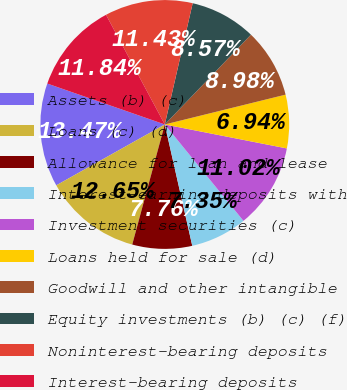Convert chart. <chart><loc_0><loc_0><loc_500><loc_500><pie_chart><fcel>Assets (b) (c)<fcel>Loans (c) (d)<fcel>Allowance for loan and lease<fcel>Interest-earning deposits with<fcel>Investment securities (c)<fcel>Loans held for sale (d)<fcel>Goodwill and other intangible<fcel>Equity investments (b) (c) (f)<fcel>Noninterest-bearing deposits<fcel>Interest-bearing deposits<nl><fcel>13.47%<fcel>12.65%<fcel>7.76%<fcel>7.35%<fcel>11.02%<fcel>6.94%<fcel>8.98%<fcel>8.57%<fcel>11.43%<fcel>11.84%<nl></chart> 